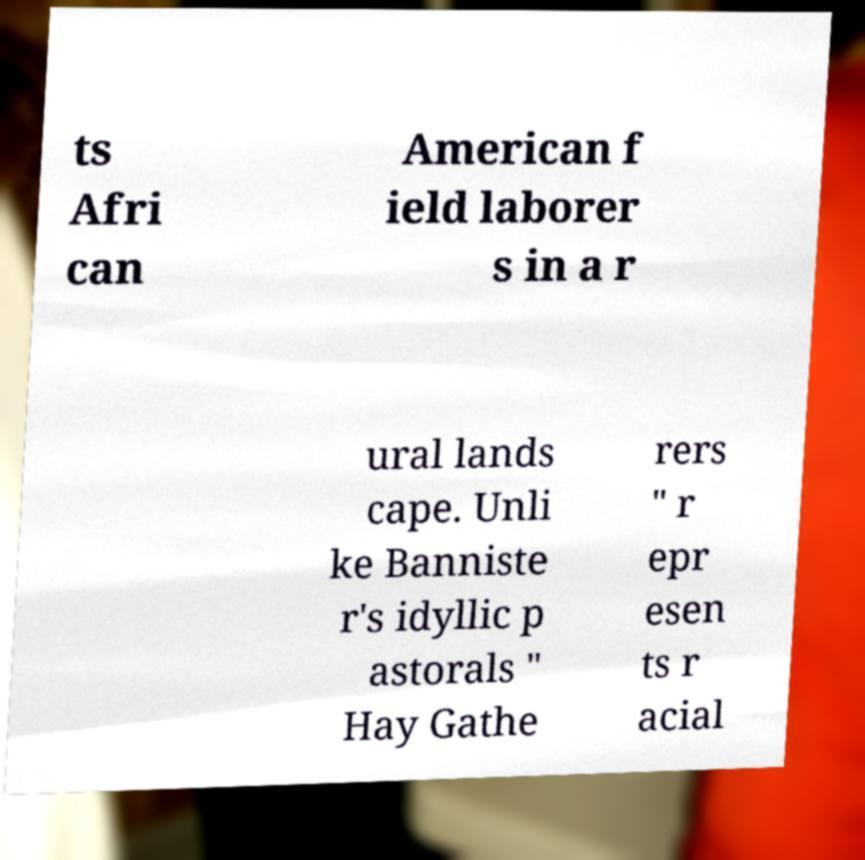For documentation purposes, I need the text within this image transcribed. Could you provide that? ts Afri can American f ield laborer s in a r ural lands cape. Unli ke Banniste r's idyllic p astorals " Hay Gathe rers " r epr esen ts r acial 